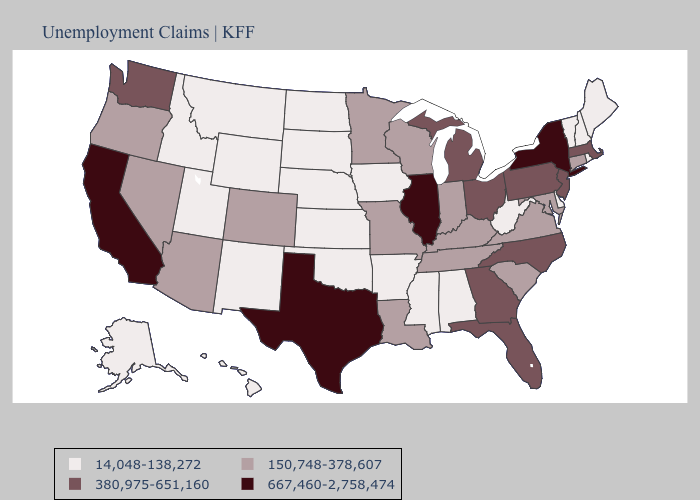What is the value of Illinois?
Short answer required. 667,460-2,758,474. What is the highest value in the MidWest ?
Give a very brief answer. 667,460-2,758,474. Does Arizona have the lowest value in the West?
Short answer required. No. What is the lowest value in states that border Illinois?
Short answer required. 14,048-138,272. Does Rhode Island have the same value as Hawaii?
Answer briefly. Yes. What is the value of Michigan?
Quick response, please. 380,975-651,160. Does the map have missing data?
Be succinct. No. What is the lowest value in the West?
Keep it brief. 14,048-138,272. Does the map have missing data?
Short answer required. No. What is the lowest value in the USA?
Write a very short answer. 14,048-138,272. What is the highest value in the USA?
Answer briefly. 667,460-2,758,474. What is the value of Maine?
Answer briefly. 14,048-138,272. Which states hav the highest value in the Northeast?
Keep it brief. New York. Among the states that border Louisiana , does Texas have the lowest value?
Answer briefly. No. Among the states that border Nebraska , which have the lowest value?
Keep it brief. Iowa, Kansas, South Dakota, Wyoming. 